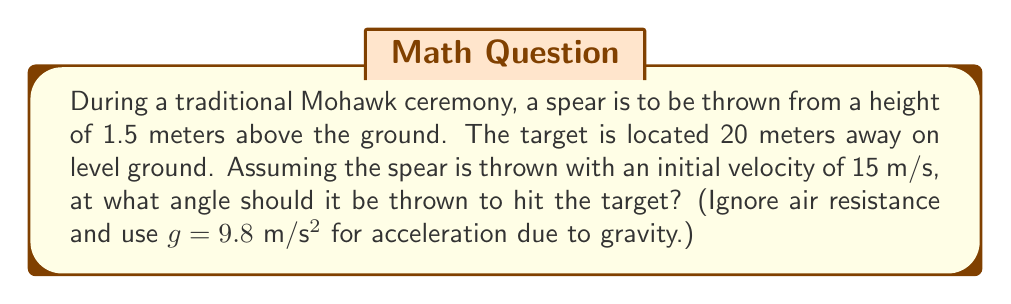What is the answer to this math problem? Let's approach this step-by-step using projectile motion equations and trigonometry:

1) We can use the equation for the range of a projectile:
   $$ R = \frac{v^2 \sin(2\theta)}{g} $$
   where R is the range, v is the initial velocity, θ is the angle, and g is acceleration due to gravity.

2) We know R = 20 m, v = 15 m/s, and g = 9.8 m/s². Substituting these values:
   $$ 20 = \frac{15^2 \sin(2\theta)}{9.8} $$

3) Simplify:
   $$ 20 = \frac{225 \sin(2\theta)}{9.8} $$
   $$ 20 \cdot 9.8 = 225 \sin(2\theta) $$
   $$ 196 = 225 \sin(2\theta) $$

4) Solve for $\sin(2\theta)$:
   $$ \sin(2\theta) = \frac{196}{225} \approx 0.8711 $$

5) Take the inverse sine (arcsin) of both sides:
   $$ 2\theta = \arcsin(0.8711) \approx 1.0508 \text{ radians} $$

6) Solve for θ:
   $$ \theta = \frac{1.0508}{2} \approx 0.5254 \text{ radians} $$

7) Convert to degrees:
   $$ \theta \approx 0.5254 \cdot \frac{180}{\pi} \approx 30.1° $$

8) However, we need to account for the initial height of 1.5 m. This will slightly reduce the required angle. We can use the quadratic equation for the trajectory:
   $$ y = x \tan(\theta) - \frac{gx^2}{2v^2\cos^2(\theta)} + 1.5 $$

9) At the target, y = 0 and x = 20. Solving this equation numerically (as it's complex to solve analytically) gives us the final answer.
Answer: $\theta \approx 29.7°$ 